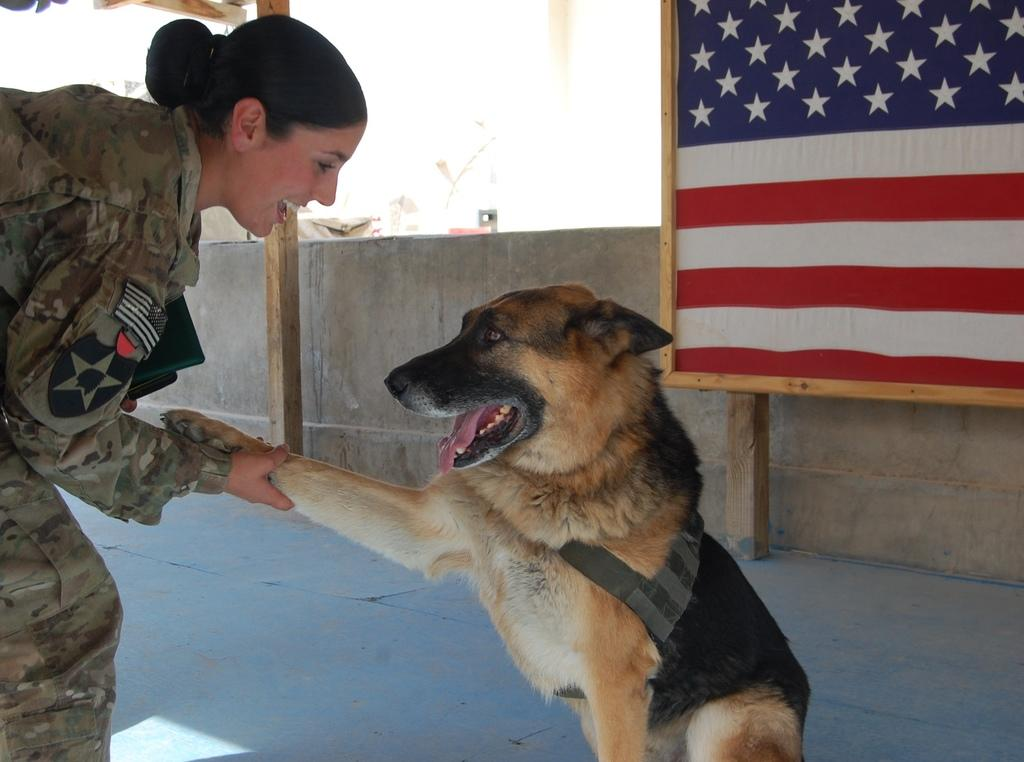Who is present in the image? There is a woman in the image. What is the woman doing in the image? The woman is standing and smiling in the image. What is the woman holding in the image? The woman is holding a dog in the image. What can be seen in the background of the image? There is a wall and a flag visible in the image. What type of star can be seen shining brightly in the image? There is no star visible in the image; it features a woman holding a dog with a wall and a flag in the background. 